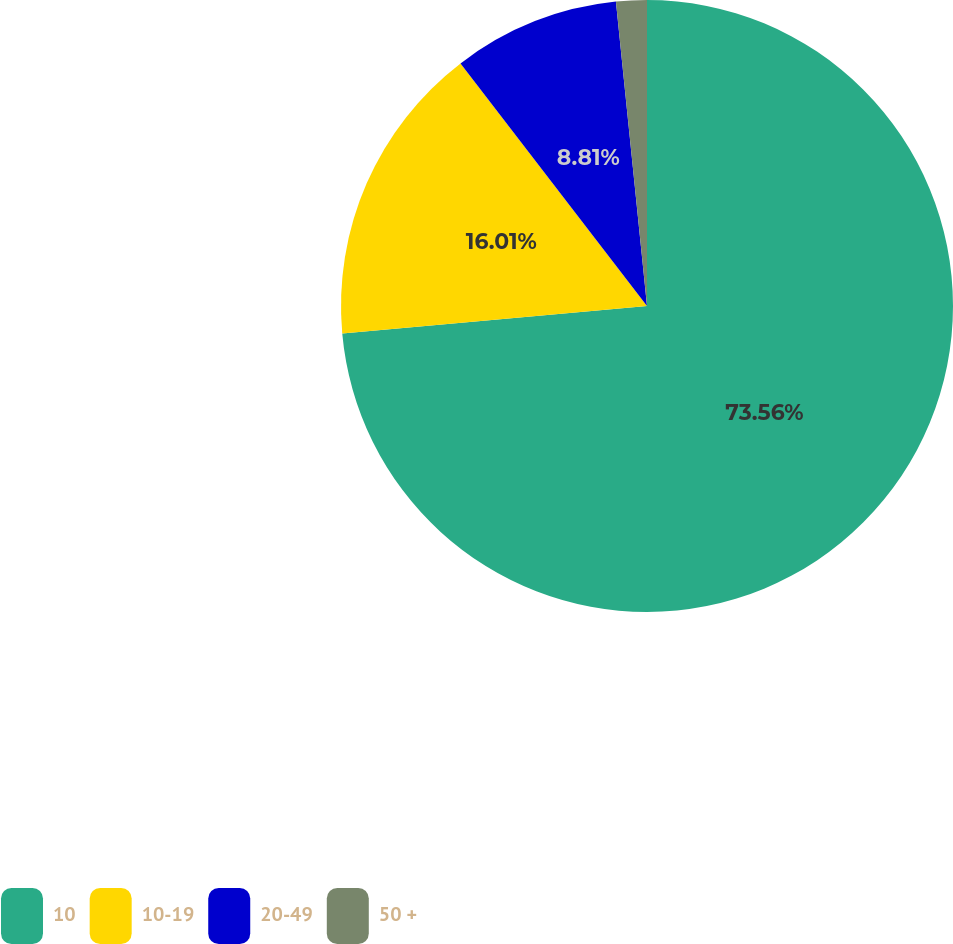Convert chart. <chart><loc_0><loc_0><loc_500><loc_500><pie_chart><fcel>10<fcel>10-19<fcel>20-49<fcel>50 +<nl><fcel>73.57%<fcel>16.01%<fcel>8.81%<fcel>1.62%<nl></chart> 